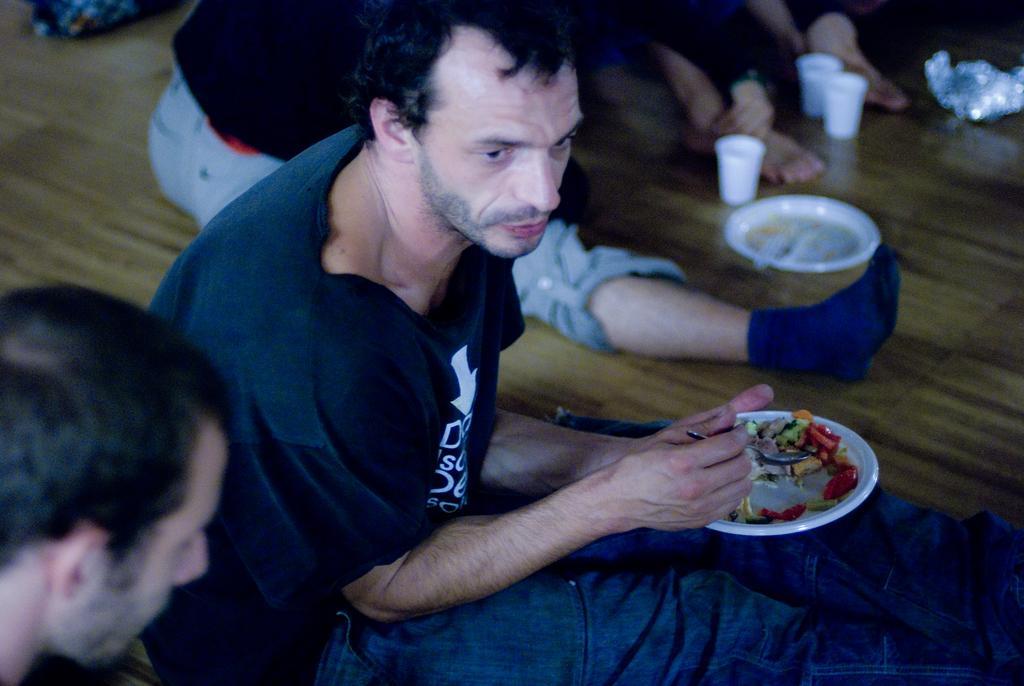Could you give a brief overview of what you see in this image? In this image few people are sitting on the ground. This person is holding a plate and a spoon. There are few plates, cups on the floor. 